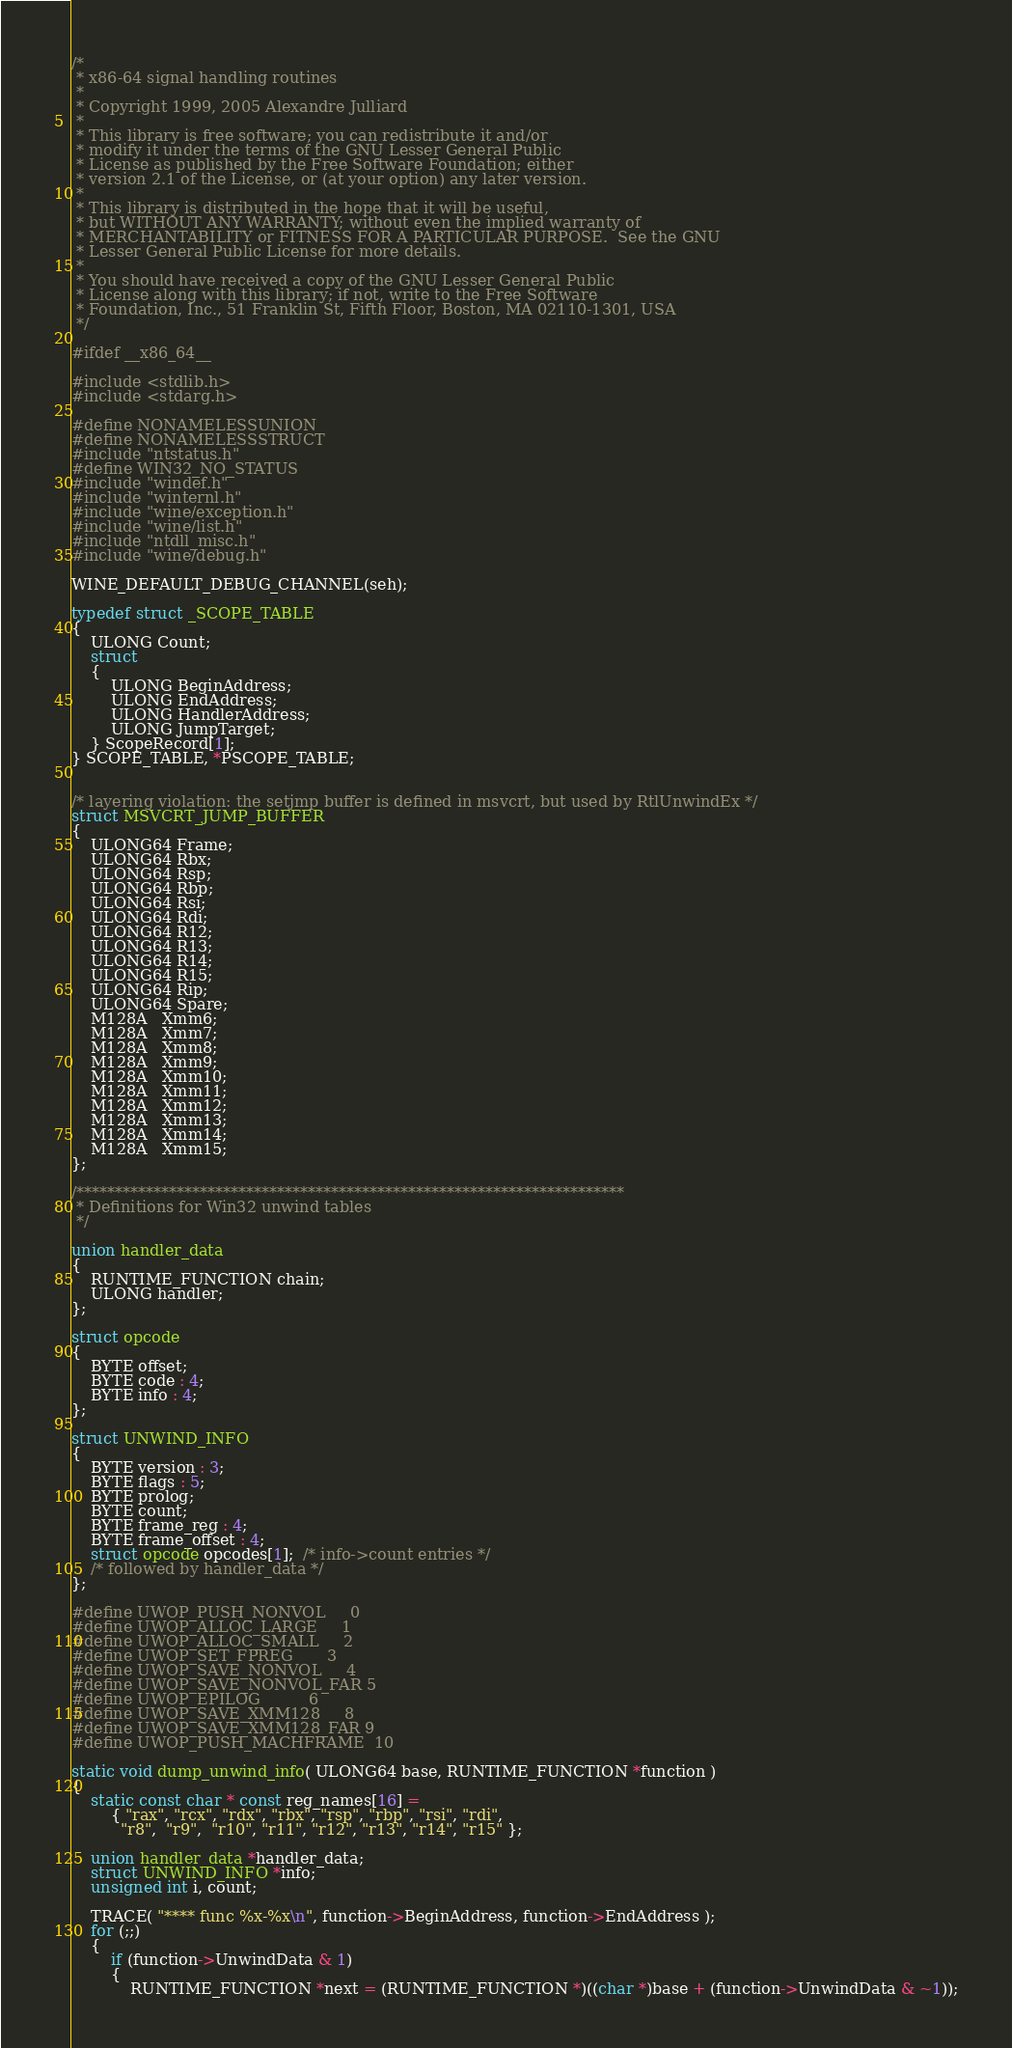<code> <loc_0><loc_0><loc_500><loc_500><_C_>/*
 * x86-64 signal handling routines
 *
 * Copyright 1999, 2005 Alexandre Julliard
 *
 * This library is free software; you can redistribute it and/or
 * modify it under the terms of the GNU Lesser General Public
 * License as published by the Free Software Foundation; either
 * version 2.1 of the License, or (at your option) any later version.
 *
 * This library is distributed in the hope that it will be useful,
 * but WITHOUT ANY WARRANTY; without even the implied warranty of
 * MERCHANTABILITY or FITNESS FOR A PARTICULAR PURPOSE.  See the GNU
 * Lesser General Public License for more details.
 *
 * You should have received a copy of the GNU Lesser General Public
 * License along with this library; if not, write to the Free Software
 * Foundation, Inc., 51 Franklin St, Fifth Floor, Boston, MA 02110-1301, USA
 */

#ifdef __x86_64__

#include <stdlib.h>
#include <stdarg.h>

#define NONAMELESSUNION
#define NONAMELESSSTRUCT
#include "ntstatus.h"
#define WIN32_NO_STATUS
#include "windef.h"
#include "winternl.h"
#include "wine/exception.h"
#include "wine/list.h"
#include "ntdll_misc.h"
#include "wine/debug.h"

WINE_DEFAULT_DEBUG_CHANNEL(seh);

typedef struct _SCOPE_TABLE
{
    ULONG Count;
    struct
    {
        ULONG BeginAddress;
        ULONG EndAddress;
        ULONG HandlerAddress;
        ULONG JumpTarget;
    } ScopeRecord[1];
} SCOPE_TABLE, *PSCOPE_TABLE;


/* layering violation: the setjmp buffer is defined in msvcrt, but used by RtlUnwindEx */
struct MSVCRT_JUMP_BUFFER
{
    ULONG64 Frame;
    ULONG64 Rbx;
    ULONG64 Rsp;
    ULONG64 Rbp;
    ULONG64 Rsi;
    ULONG64 Rdi;
    ULONG64 R12;
    ULONG64 R13;
    ULONG64 R14;
    ULONG64 R15;
    ULONG64 Rip;
    ULONG64 Spare;
    M128A   Xmm6;
    M128A   Xmm7;
    M128A   Xmm8;
    M128A   Xmm9;
    M128A   Xmm10;
    M128A   Xmm11;
    M128A   Xmm12;
    M128A   Xmm13;
    M128A   Xmm14;
    M128A   Xmm15;
};

/***********************************************************************
 * Definitions for Win32 unwind tables
 */

union handler_data
{
    RUNTIME_FUNCTION chain;
    ULONG handler;
};

struct opcode
{
    BYTE offset;
    BYTE code : 4;
    BYTE info : 4;
};

struct UNWIND_INFO
{
    BYTE version : 3;
    BYTE flags : 5;
    BYTE prolog;
    BYTE count;
    BYTE frame_reg : 4;
    BYTE frame_offset : 4;
    struct opcode opcodes[1];  /* info->count entries */
    /* followed by handler_data */
};

#define UWOP_PUSH_NONVOL     0
#define UWOP_ALLOC_LARGE     1
#define UWOP_ALLOC_SMALL     2
#define UWOP_SET_FPREG       3
#define UWOP_SAVE_NONVOL     4
#define UWOP_SAVE_NONVOL_FAR 5
#define UWOP_EPILOG          6
#define UWOP_SAVE_XMM128     8
#define UWOP_SAVE_XMM128_FAR 9
#define UWOP_PUSH_MACHFRAME  10

static void dump_unwind_info( ULONG64 base, RUNTIME_FUNCTION *function )
{
    static const char * const reg_names[16] =
        { "rax", "rcx", "rdx", "rbx", "rsp", "rbp", "rsi", "rdi",
          "r8",  "r9",  "r10", "r11", "r12", "r13", "r14", "r15" };

    union handler_data *handler_data;
    struct UNWIND_INFO *info;
    unsigned int i, count;

    TRACE( "**** func %x-%x\n", function->BeginAddress, function->EndAddress );
    for (;;)
    {
        if (function->UnwindData & 1)
        {
            RUNTIME_FUNCTION *next = (RUNTIME_FUNCTION *)((char *)base + (function->UnwindData & ~1));</code> 